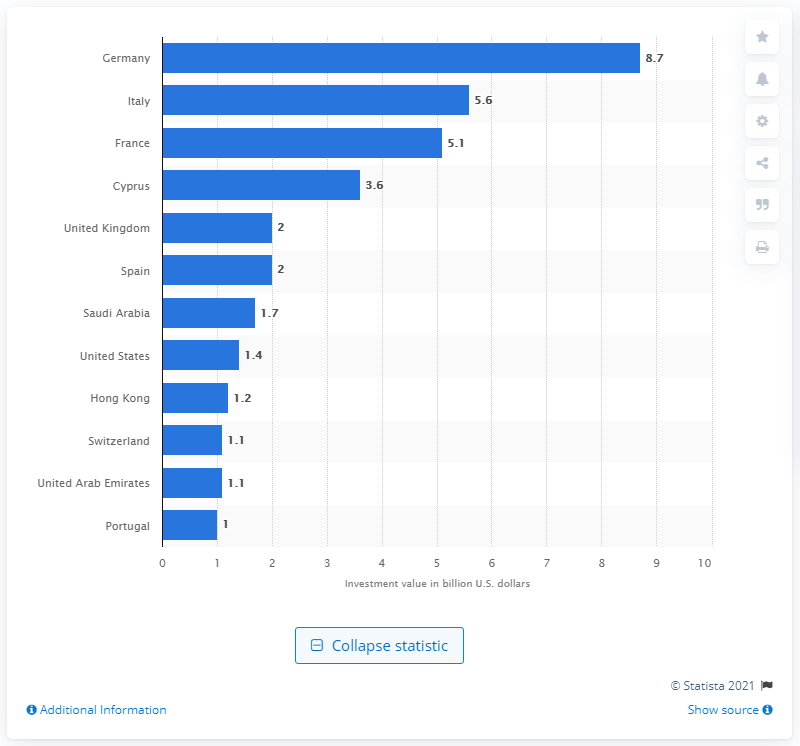Identify some key points in this picture. Italy was the second biggest dealmaker in Greece between 2005 and 2015. Germany spent approximately 8.7 billion euros investing in private enterprises in Greece between 2005 and 2015. 